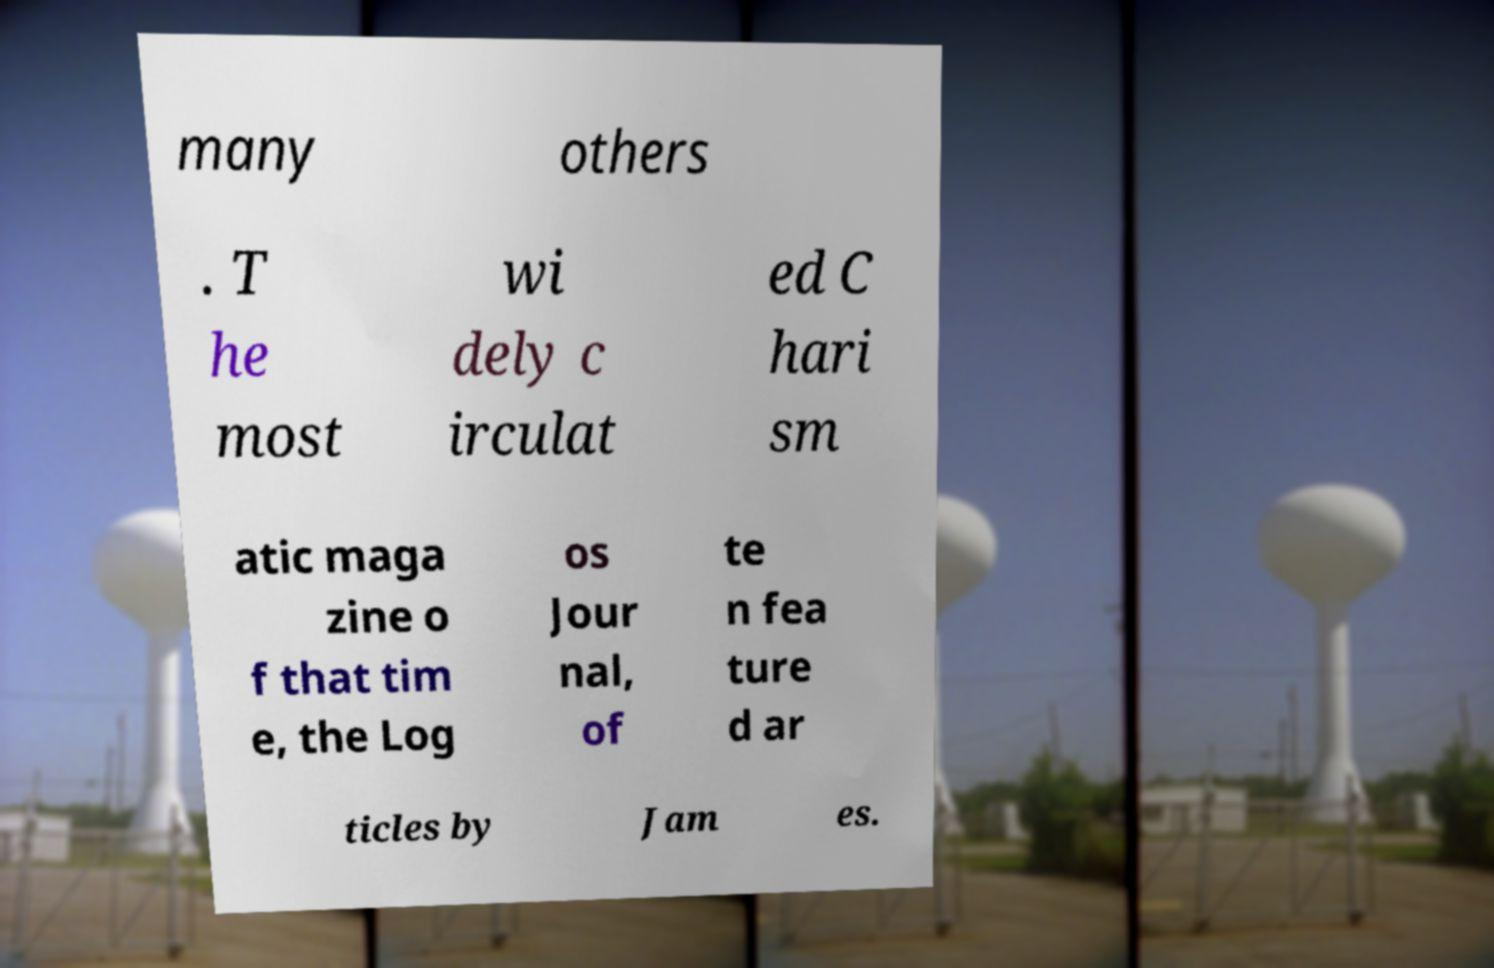Please identify and transcribe the text found in this image. many others . T he most wi dely c irculat ed C hari sm atic maga zine o f that tim e, the Log os Jour nal, of te n fea ture d ar ticles by Jam es. 